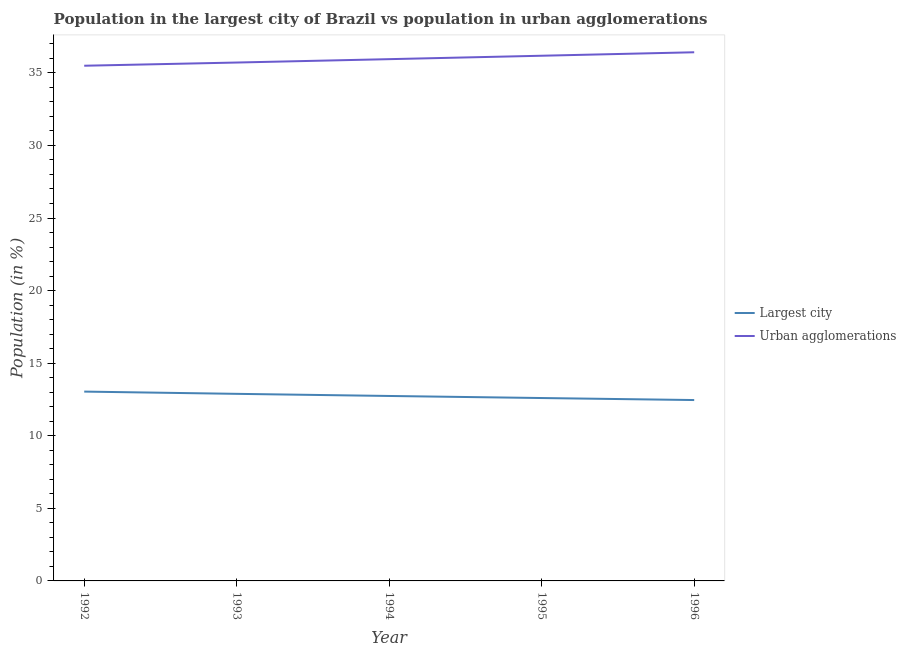Does the line corresponding to population in the largest city intersect with the line corresponding to population in urban agglomerations?
Provide a succinct answer. No. What is the population in urban agglomerations in 1993?
Provide a succinct answer. 35.71. Across all years, what is the maximum population in the largest city?
Your response must be concise. 13.04. Across all years, what is the minimum population in urban agglomerations?
Provide a succinct answer. 35.49. What is the total population in the largest city in the graph?
Offer a terse response. 63.73. What is the difference between the population in urban agglomerations in 1993 and that in 1995?
Provide a short and direct response. -0.47. What is the difference between the population in urban agglomerations in 1993 and the population in the largest city in 1995?
Ensure brevity in your answer.  23.11. What is the average population in urban agglomerations per year?
Provide a succinct answer. 35.95. In the year 1993, what is the difference between the population in the largest city and population in urban agglomerations?
Give a very brief answer. -22.82. What is the ratio of the population in urban agglomerations in 1992 to that in 1994?
Provide a short and direct response. 0.99. Is the population in the largest city in 1993 less than that in 1995?
Make the answer very short. No. Is the difference between the population in urban agglomerations in 1992 and 1995 greater than the difference between the population in the largest city in 1992 and 1995?
Make the answer very short. No. What is the difference between the highest and the second highest population in urban agglomerations?
Your answer should be very brief. 0.24. What is the difference between the highest and the lowest population in the largest city?
Make the answer very short. 0.58. In how many years, is the population in the largest city greater than the average population in the largest city taken over all years?
Ensure brevity in your answer.  2. Is the sum of the population in urban agglomerations in 1993 and 1996 greater than the maximum population in the largest city across all years?
Offer a terse response. Yes. Does the population in the largest city monotonically increase over the years?
Give a very brief answer. No. Is the population in the largest city strictly greater than the population in urban agglomerations over the years?
Provide a short and direct response. No. Is the population in urban agglomerations strictly less than the population in the largest city over the years?
Your answer should be compact. No. How many lines are there?
Your response must be concise. 2. What is the difference between two consecutive major ticks on the Y-axis?
Your response must be concise. 5. Does the graph contain any zero values?
Provide a succinct answer. No. Does the graph contain grids?
Offer a terse response. No. Where does the legend appear in the graph?
Your answer should be very brief. Center right. How are the legend labels stacked?
Give a very brief answer. Vertical. What is the title of the graph?
Your answer should be compact. Population in the largest city of Brazil vs population in urban agglomerations. Does "By country of origin" appear as one of the legend labels in the graph?
Offer a very short reply. No. What is the label or title of the Y-axis?
Offer a very short reply. Population (in %). What is the Population (in %) in Largest city in 1992?
Give a very brief answer. 13.04. What is the Population (in %) in Urban agglomerations in 1992?
Make the answer very short. 35.49. What is the Population (in %) of Largest city in 1993?
Ensure brevity in your answer.  12.89. What is the Population (in %) of Urban agglomerations in 1993?
Your answer should be compact. 35.71. What is the Population (in %) of Largest city in 1994?
Provide a short and direct response. 12.74. What is the Population (in %) of Urban agglomerations in 1994?
Provide a short and direct response. 35.94. What is the Population (in %) in Largest city in 1995?
Your response must be concise. 12.6. What is the Population (in %) in Urban agglomerations in 1995?
Your answer should be compact. 36.18. What is the Population (in %) in Largest city in 1996?
Your answer should be compact. 12.46. What is the Population (in %) in Urban agglomerations in 1996?
Provide a short and direct response. 36.42. Across all years, what is the maximum Population (in %) in Largest city?
Make the answer very short. 13.04. Across all years, what is the maximum Population (in %) of Urban agglomerations?
Give a very brief answer. 36.42. Across all years, what is the minimum Population (in %) in Largest city?
Ensure brevity in your answer.  12.46. Across all years, what is the minimum Population (in %) of Urban agglomerations?
Make the answer very short. 35.49. What is the total Population (in %) in Largest city in the graph?
Provide a short and direct response. 63.73. What is the total Population (in %) of Urban agglomerations in the graph?
Keep it short and to the point. 179.74. What is the difference between the Population (in %) of Largest city in 1992 and that in 1993?
Your answer should be very brief. 0.15. What is the difference between the Population (in %) in Urban agglomerations in 1992 and that in 1993?
Keep it short and to the point. -0.22. What is the difference between the Population (in %) in Largest city in 1992 and that in 1994?
Offer a terse response. 0.3. What is the difference between the Population (in %) in Urban agglomerations in 1992 and that in 1994?
Offer a very short reply. -0.45. What is the difference between the Population (in %) in Largest city in 1992 and that in 1995?
Offer a very short reply. 0.44. What is the difference between the Population (in %) of Urban agglomerations in 1992 and that in 1995?
Your answer should be compact. -0.69. What is the difference between the Population (in %) in Largest city in 1992 and that in 1996?
Provide a short and direct response. 0.58. What is the difference between the Population (in %) in Urban agglomerations in 1992 and that in 1996?
Make the answer very short. -0.93. What is the difference between the Population (in %) in Largest city in 1993 and that in 1994?
Offer a terse response. 0.15. What is the difference between the Population (in %) in Urban agglomerations in 1993 and that in 1994?
Make the answer very short. -0.23. What is the difference between the Population (in %) in Largest city in 1993 and that in 1995?
Offer a terse response. 0.29. What is the difference between the Population (in %) of Urban agglomerations in 1993 and that in 1995?
Provide a succinct answer. -0.47. What is the difference between the Population (in %) in Largest city in 1993 and that in 1996?
Provide a short and direct response. 0.43. What is the difference between the Population (in %) in Urban agglomerations in 1993 and that in 1996?
Your answer should be very brief. -0.71. What is the difference between the Population (in %) of Largest city in 1994 and that in 1995?
Your answer should be compact. 0.14. What is the difference between the Population (in %) in Urban agglomerations in 1994 and that in 1995?
Offer a terse response. -0.24. What is the difference between the Population (in %) of Largest city in 1994 and that in 1996?
Your answer should be compact. 0.28. What is the difference between the Population (in %) in Urban agglomerations in 1994 and that in 1996?
Your answer should be compact. -0.47. What is the difference between the Population (in %) in Largest city in 1995 and that in 1996?
Ensure brevity in your answer.  0.14. What is the difference between the Population (in %) in Urban agglomerations in 1995 and that in 1996?
Ensure brevity in your answer.  -0.24. What is the difference between the Population (in %) of Largest city in 1992 and the Population (in %) of Urban agglomerations in 1993?
Give a very brief answer. -22.67. What is the difference between the Population (in %) of Largest city in 1992 and the Population (in %) of Urban agglomerations in 1994?
Make the answer very short. -22.9. What is the difference between the Population (in %) in Largest city in 1992 and the Population (in %) in Urban agglomerations in 1995?
Your response must be concise. -23.14. What is the difference between the Population (in %) in Largest city in 1992 and the Population (in %) in Urban agglomerations in 1996?
Offer a very short reply. -23.38. What is the difference between the Population (in %) of Largest city in 1993 and the Population (in %) of Urban agglomerations in 1994?
Make the answer very short. -23.06. What is the difference between the Population (in %) of Largest city in 1993 and the Population (in %) of Urban agglomerations in 1995?
Provide a short and direct response. -23.29. What is the difference between the Population (in %) in Largest city in 1993 and the Population (in %) in Urban agglomerations in 1996?
Keep it short and to the point. -23.53. What is the difference between the Population (in %) in Largest city in 1994 and the Population (in %) in Urban agglomerations in 1995?
Make the answer very short. -23.44. What is the difference between the Population (in %) in Largest city in 1994 and the Population (in %) in Urban agglomerations in 1996?
Provide a short and direct response. -23.68. What is the difference between the Population (in %) of Largest city in 1995 and the Population (in %) of Urban agglomerations in 1996?
Your answer should be very brief. -23.82. What is the average Population (in %) in Largest city per year?
Offer a very short reply. 12.75. What is the average Population (in %) of Urban agglomerations per year?
Offer a very short reply. 35.95. In the year 1992, what is the difference between the Population (in %) in Largest city and Population (in %) in Urban agglomerations?
Keep it short and to the point. -22.45. In the year 1993, what is the difference between the Population (in %) of Largest city and Population (in %) of Urban agglomerations?
Keep it short and to the point. -22.82. In the year 1994, what is the difference between the Population (in %) in Largest city and Population (in %) in Urban agglomerations?
Offer a terse response. -23.2. In the year 1995, what is the difference between the Population (in %) in Largest city and Population (in %) in Urban agglomerations?
Make the answer very short. -23.58. In the year 1996, what is the difference between the Population (in %) of Largest city and Population (in %) of Urban agglomerations?
Give a very brief answer. -23.96. What is the ratio of the Population (in %) of Largest city in 1992 to that in 1993?
Your answer should be very brief. 1.01. What is the ratio of the Population (in %) in Urban agglomerations in 1992 to that in 1993?
Offer a terse response. 0.99. What is the ratio of the Population (in %) of Largest city in 1992 to that in 1994?
Provide a short and direct response. 1.02. What is the ratio of the Population (in %) in Urban agglomerations in 1992 to that in 1994?
Provide a short and direct response. 0.99. What is the ratio of the Population (in %) of Largest city in 1992 to that in 1995?
Give a very brief answer. 1.04. What is the ratio of the Population (in %) in Urban agglomerations in 1992 to that in 1995?
Your answer should be very brief. 0.98. What is the ratio of the Population (in %) in Largest city in 1992 to that in 1996?
Ensure brevity in your answer.  1.05. What is the ratio of the Population (in %) in Urban agglomerations in 1992 to that in 1996?
Your answer should be very brief. 0.97. What is the ratio of the Population (in %) of Largest city in 1993 to that in 1994?
Offer a terse response. 1.01. What is the ratio of the Population (in %) in Largest city in 1993 to that in 1995?
Offer a terse response. 1.02. What is the ratio of the Population (in %) of Urban agglomerations in 1993 to that in 1995?
Offer a very short reply. 0.99. What is the ratio of the Population (in %) in Largest city in 1993 to that in 1996?
Offer a very short reply. 1.03. What is the ratio of the Population (in %) in Urban agglomerations in 1993 to that in 1996?
Give a very brief answer. 0.98. What is the ratio of the Population (in %) in Largest city in 1994 to that in 1995?
Make the answer very short. 1.01. What is the ratio of the Population (in %) in Largest city in 1994 to that in 1996?
Your response must be concise. 1.02. What is the ratio of the Population (in %) in Urban agglomerations in 1994 to that in 1996?
Keep it short and to the point. 0.99. What is the ratio of the Population (in %) in Largest city in 1995 to that in 1996?
Your response must be concise. 1.01. What is the ratio of the Population (in %) of Urban agglomerations in 1995 to that in 1996?
Give a very brief answer. 0.99. What is the difference between the highest and the second highest Population (in %) of Largest city?
Your answer should be compact. 0.15. What is the difference between the highest and the second highest Population (in %) of Urban agglomerations?
Make the answer very short. 0.24. What is the difference between the highest and the lowest Population (in %) in Largest city?
Your answer should be very brief. 0.58. What is the difference between the highest and the lowest Population (in %) in Urban agglomerations?
Provide a short and direct response. 0.93. 